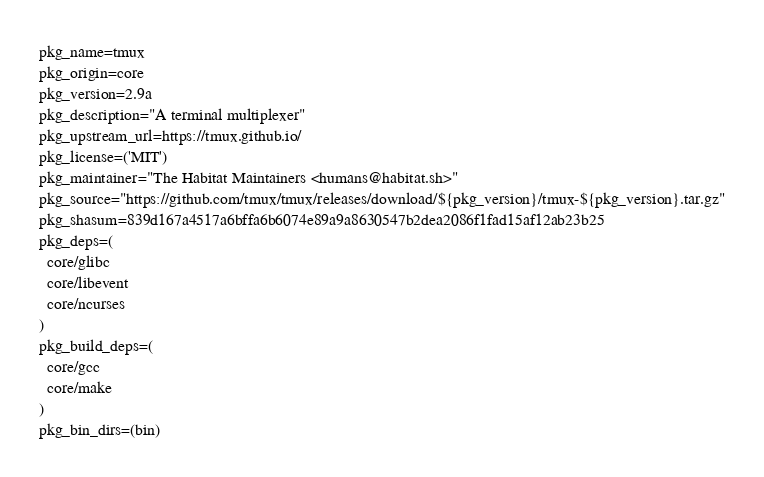Convert code to text. <code><loc_0><loc_0><loc_500><loc_500><_Bash_>pkg_name=tmux
pkg_origin=core
pkg_version=2.9a
pkg_description="A terminal multiplexer"
pkg_upstream_url=https://tmux.github.io/
pkg_license=('MIT')
pkg_maintainer="The Habitat Maintainers <humans@habitat.sh>"
pkg_source="https://github.com/tmux/tmux/releases/download/${pkg_version}/tmux-${pkg_version}.tar.gz"
pkg_shasum=839d167a4517a6bffa6b6074e89a9a8630547b2dea2086f1fad15af12ab23b25
pkg_deps=(
  core/glibc
  core/libevent
  core/ncurses
)
pkg_build_deps=(
  core/gcc
  core/make
)
pkg_bin_dirs=(bin)
</code> 